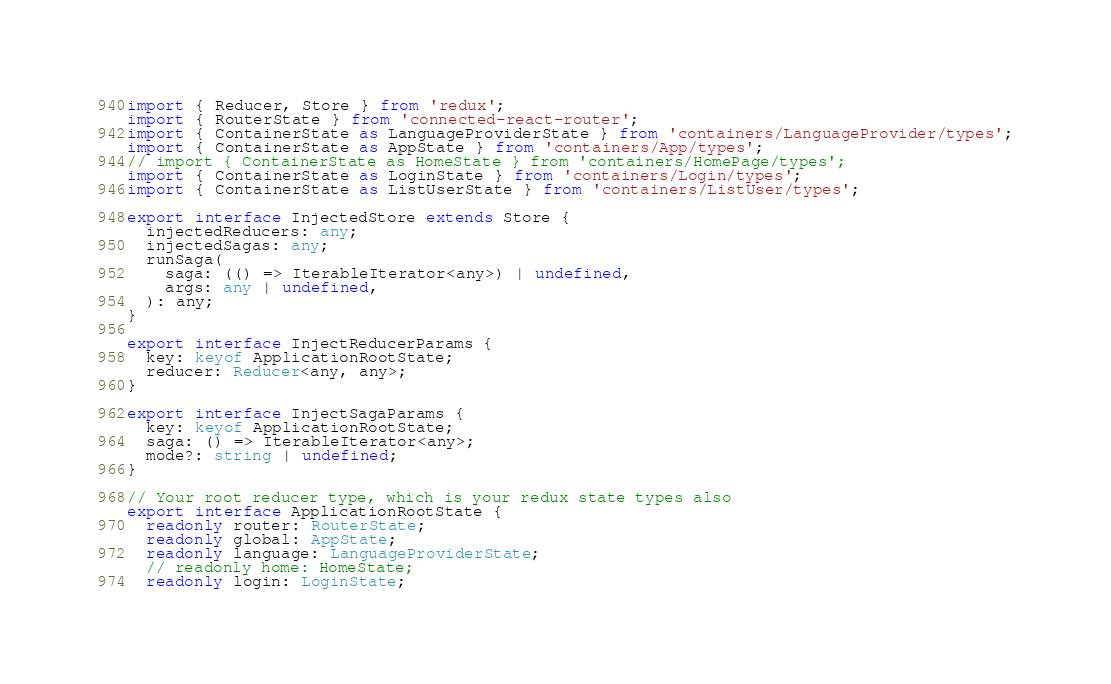Convert code to text. <code><loc_0><loc_0><loc_500><loc_500><_TypeScript_>import { Reducer, Store } from 'redux';
import { RouterState } from 'connected-react-router';
import { ContainerState as LanguageProviderState } from 'containers/LanguageProvider/types';
import { ContainerState as AppState } from 'containers/App/types';
// import { ContainerState as HomeState } from 'containers/HomePage/types';
import { ContainerState as LoginState } from 'containers/Login/types';
import { ContainerState as ListUserState } from 'containers/ListUser/types';

export interface InjectedStore extends Store {
  injectedReducers: any;
  injectedSagas: any;
  runSaga(
    saga: (() => IterableIterator<any>) | undefined,
    args: any | undefined,
  ): any;
}

export interface InjectReducerParams {
  key: keyof ApplicationRootState;
  reducer: Reducer<any, any>;
}

export interface InjectSagaParams {
  key: keyof ApplicationRootState;
  saga: () => IterableIterator<any>;
  mode?: string | undefined;
}

// Your root reducer type, which is your redux state types also
export interface ApplicationRootState {
  readonly router: RouterState;
  readonly global: AppState;
  readonly language: LanguageProviderState;
  // readonly home: HomeState;
  readonly login: LoginState;</code> 